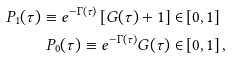<formula> <loc_0><loc_0><loc_500><loc_500>P _ { 1 } ( \tau ) \equiv e ^ { - \Gamma ( \tau ) } \left [ G ( \tau ) + 1 \right ] \in & \left [ 0 , 1 \right ] \\ P _ { 0 } ( \tau ) \equiv e ^ { - \Gamma ( \tau ) } G ( \tau ) \in & \left [ 0 , 1 \right ] ,</formula> 